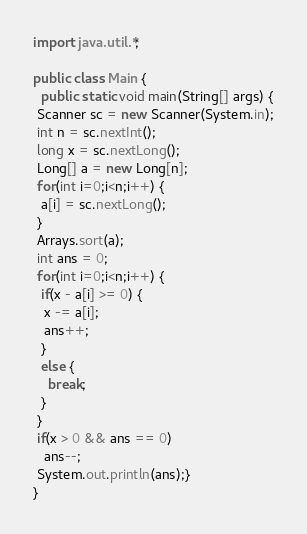Convert code to text. <code><loc_0><loc_0><loc_500><loc_500><_Java_>import java.util.*;

public class Main {
  public static void main(String[] args) {
 Scanner sc = new Scanner(System.in);
 int n = sc.nextInt();
 long x = sc.nextLong();
 Long[] a = new Long[n];
 for(int i=0;i<n;i++) {
  a[i] = sc.nextLong();
 }
 Arrays.sort(a);
 int ans = 0;
 for(int i=0;i<n;i++) {
  if(x - a[i] >= 0) {
   x -= a[i];
   ans++;
  }
  else {
    break; 
  }
 }
 if(x > 0 && ans == 0)
   ans--;
 System.out.println(ans);}
}
</code> 